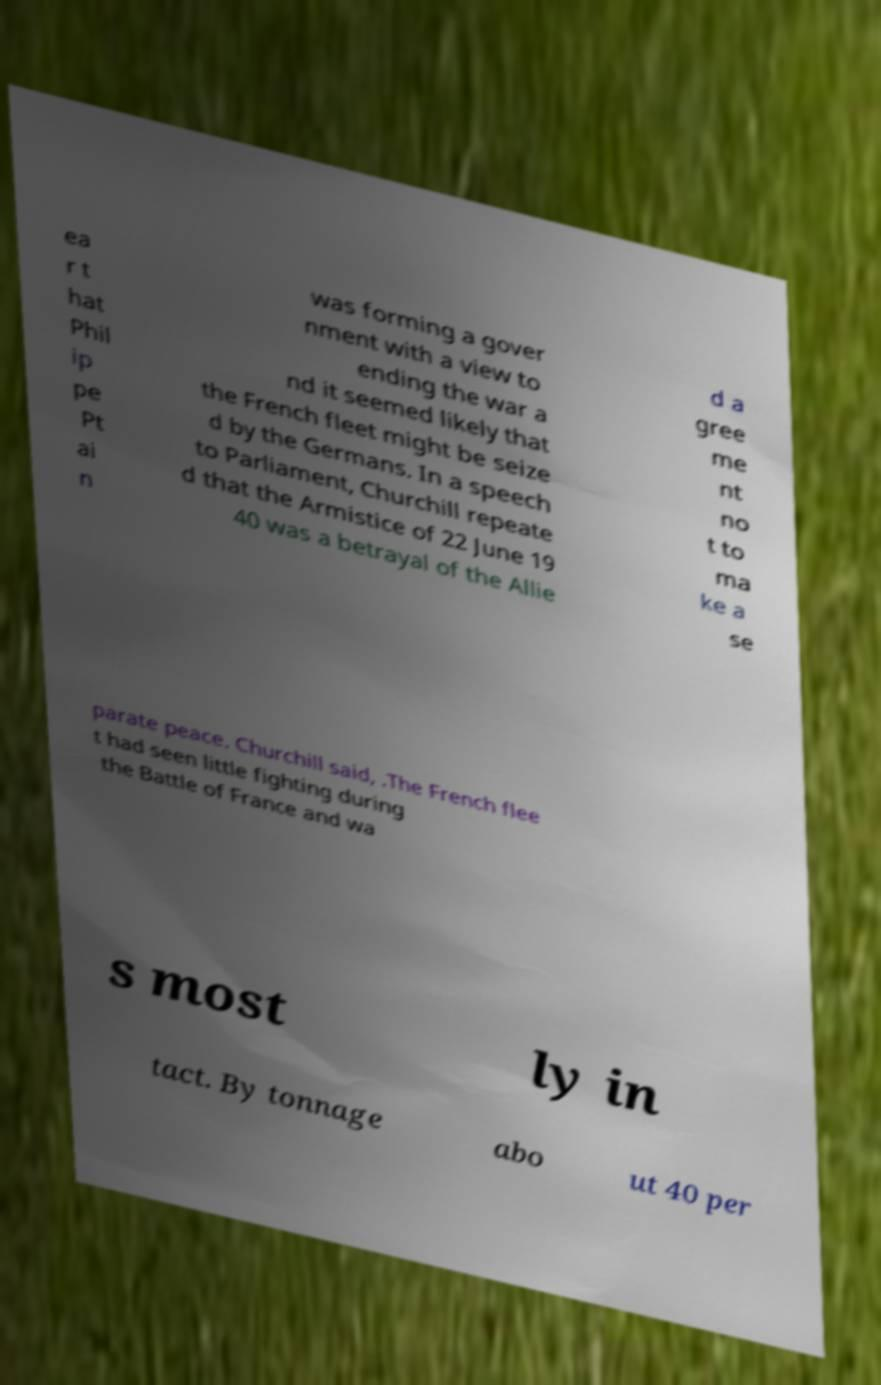Please identify and transcribe the text found in this image. ea r t hat Phil ip pe Pt ai n was forming a gover nment with a view to ending the war a nd it seemed likely that the French fleet might be seize d by the Germans. In a speech to Parliament, Churchill repeate d that the Armistice of 22 June 19 40 was a betrayal of the Allie d a gree me nt no t to ma ke a se parate peace. Churchill said, .The French flee t had seen little fighting during the Battle of France and wa s most ly in tact. By tonnage abo ut 40 per 